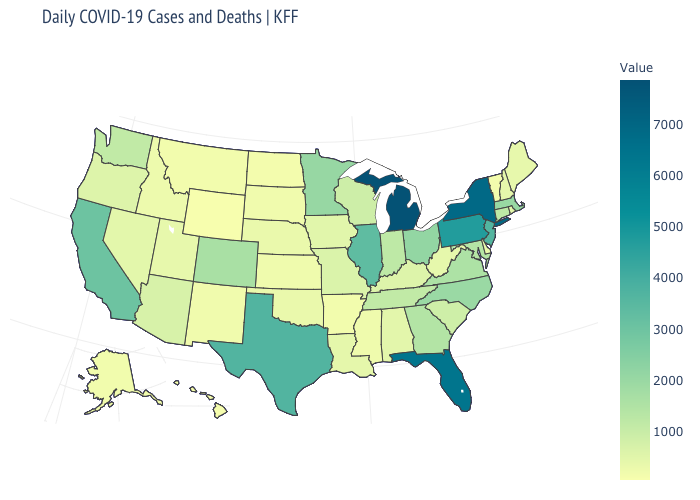Which states have the highest value in the USA?
Write a very short answer. Michigan. Does Michigan have the highest value in the USA?
Give a very brief answer. Yes. Does Ohio have the lowest value in the MidWest?
Give a very brief answer. No. Is the legend a continuous bar?
Keep it brief. Yes. Among the states that border Michigan , does Wisconsin have the lowest value?
Write a very short answer. Yes. 